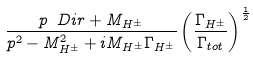<formula> <loc_0><loc_0><loc_500><loc_500>\frac { p \ D i r + M _ { H ^ { \pm } } } { p ^ { 2 } - M ^ { 2 } _ { H ^ { \pm } } + i M _ { H ^ { \pm } } \Gamma _ { H ^ { \pm } } } \left ( \frac { \Gamma _ { H ^ { \pm } } } { \Gamma _ { t o t } } \right ) ^ { \frac { 1 } { 2 } }</formula> 